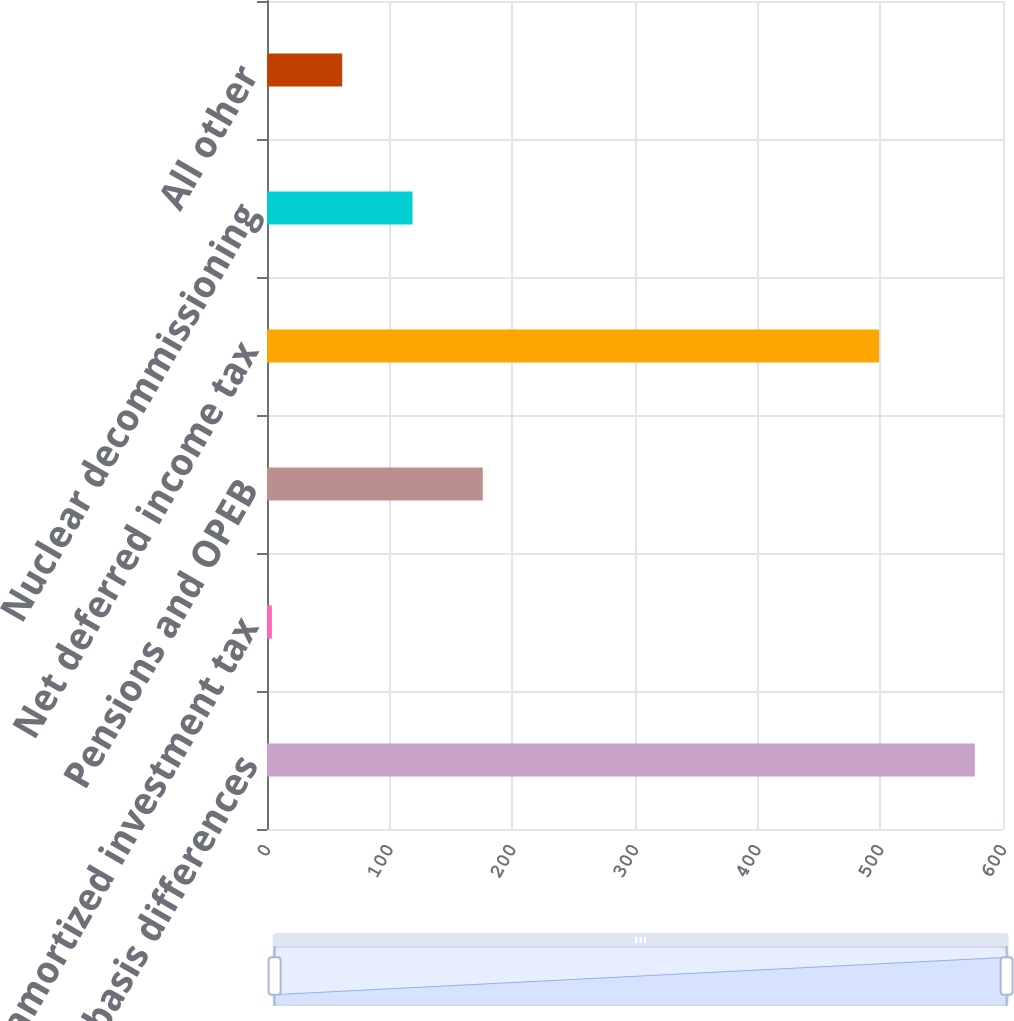Convert chart to OTSL. <chart><loc_0><loc_0><loc_500><loc_500><bar_chart><fcel>Property basis differences<fcel>Unamortized investment tax<fcel>Pensions and OPEB<fcel>Net deferred income tax<fcel>Nuclear decommissioning<fcel>All other<nl><fcel>577<fcel>4<fcel>175.9<fcel>499<fcel>118.6<fcel>61.3<nl></chart> 